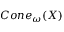<formula> <loc_0><loc_0><loc_500><loc_500>C o n e _ { \omega } ( X )</formula> 